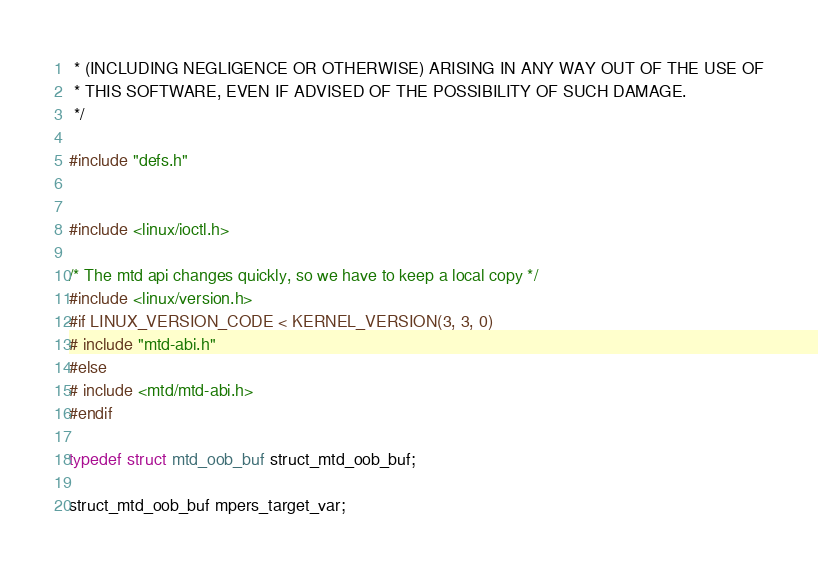Convert code to text. <code><loc_0><loc_0><loc_500><loc_500><_C_> * (INCLUDING NEGLIGENCE OR OTHERWISE) ARISING IN ANY WAY OUT OF THE USE OF
 * THIS SOFTWARE, EVEN IF ADVISED OF THE POSSIBILITY OF SUCH DAMAGE.
 */

#include "defs.h"


#include <linux/ioctl.h>

/* The mtd api changes quickly, so we have to keep a local copy */
#include <linux/version.h>
#if LINUX_VERSION_CODE < KERNEL_VERSION(3, 3, 0)
# include "mtd-abi.h"
#else
# include <mtd/mtd-abi.h>
#endif

typedef struct mtd_oob_buf struct_mtd_oob_buf;

struct_mtd_oob_buf mpers_target_var;
</code> 